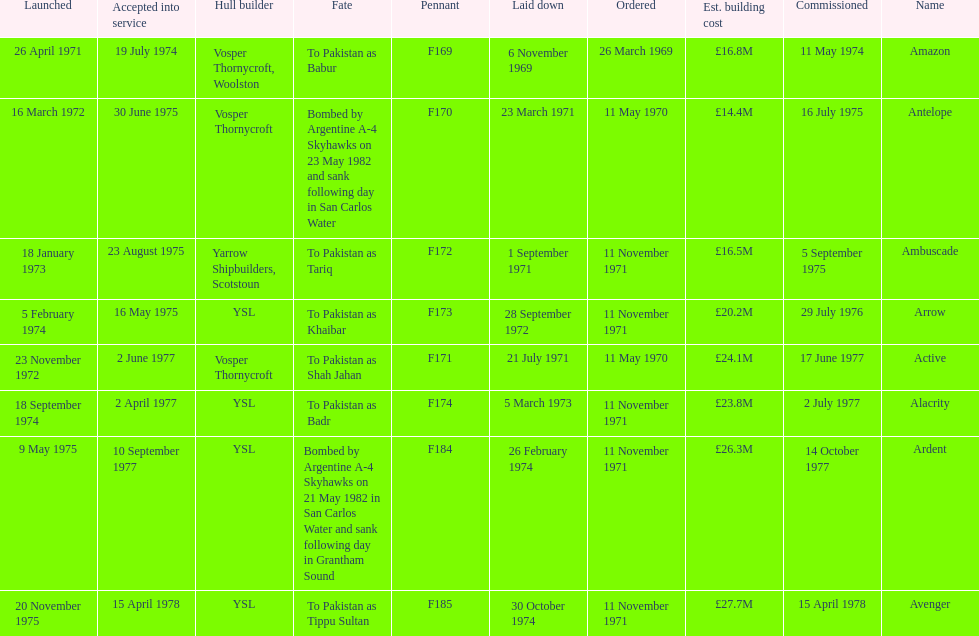What is the last listed pennant? F185. 